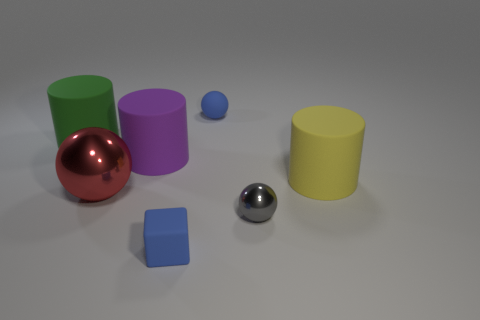Add 2 big red rubber cylinders. How many objects exist? 9 Subtract all cubes. How many objects are left? 6 Add 6 big rubber things. How many big rubber things exist? 9 Subtract 0 brown cylinders. How many objects are left? 7 Subtract all blue objects. Subtract all tiny blue matte objects. How many objects are left? 3 Add 6 large rubber cylinders. How many large rubber cylinders are left? 9 